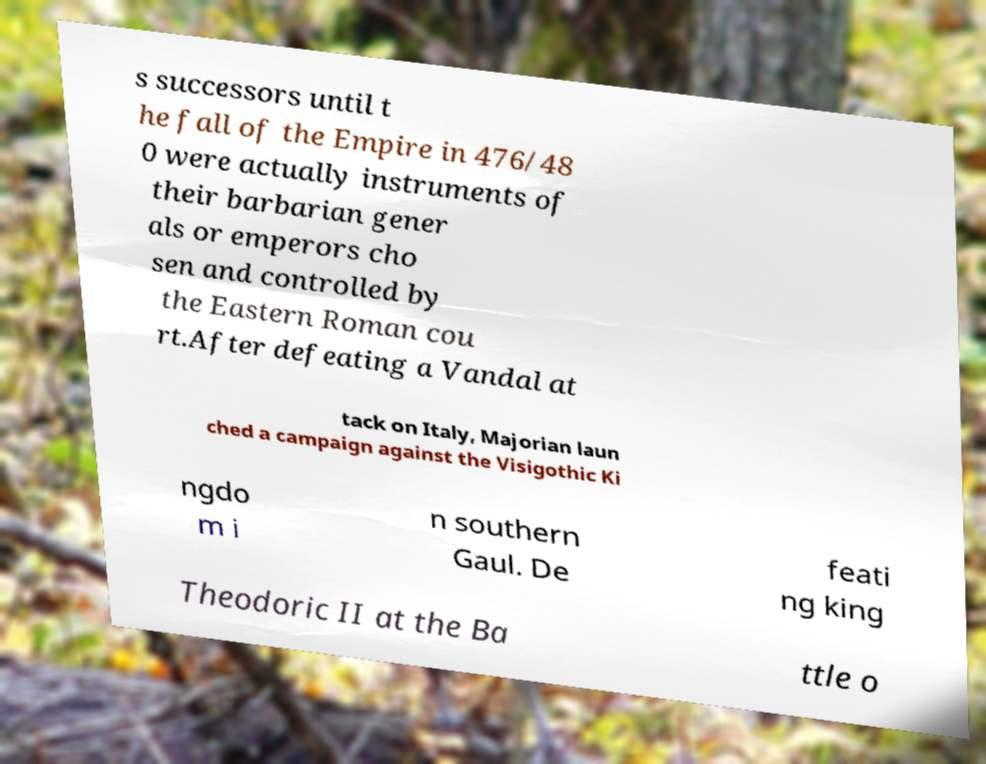I need the written content from this picture converted into text. Can you do that? s successors until t he fall of the Empire in 476/48 0 were actually instruments of their barbarian gener als or emperors cho sen and controlled by the Eastern Roman cou rt.After defeating a Vandal at tack on Italy, Majorian laun ched a campaign against the Visigothic Ki ngdo m i n southern Gaul. De feati ng king Theodoric II at the Ba ttle o 